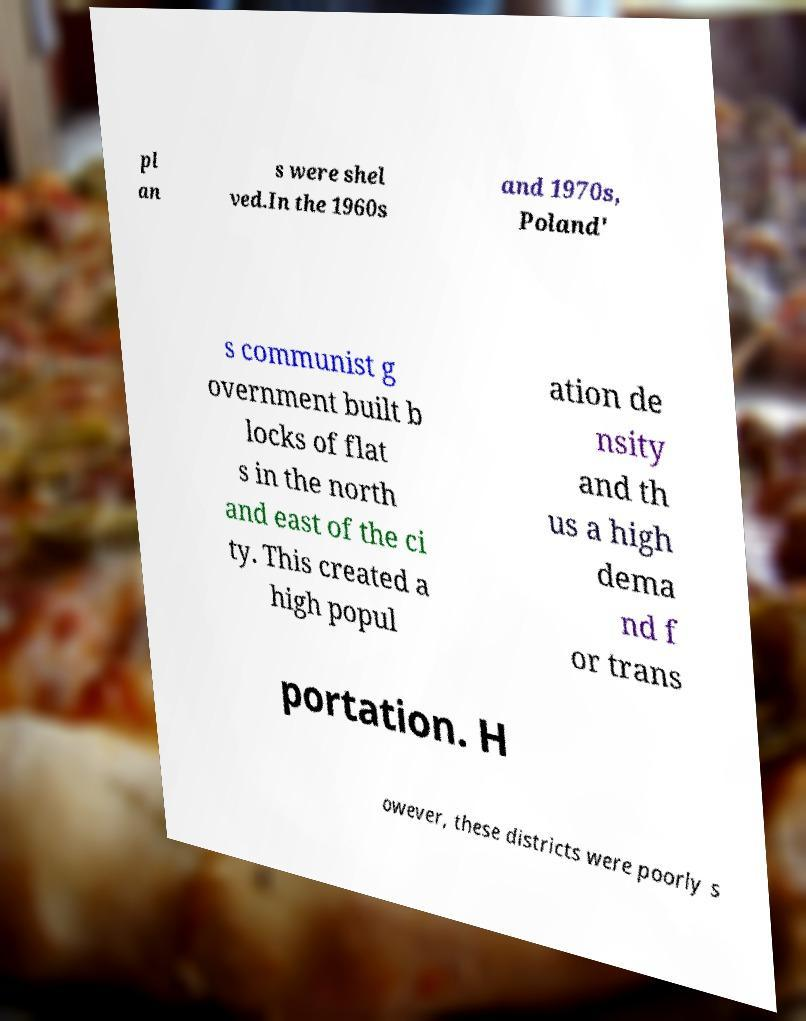Can you read and provide the text displayed in the image?This photo seems to have some interesting text. Can you extract and type it out for me? pl an s were shel ved.In the 1960s and 1970s, Poland' s communist g overnment built b locks of flat s in the north and east of the ci ty. This created a high popul ation de nsity and th us a high dema nd f or trans portation. H owever, these districts were poorly s 